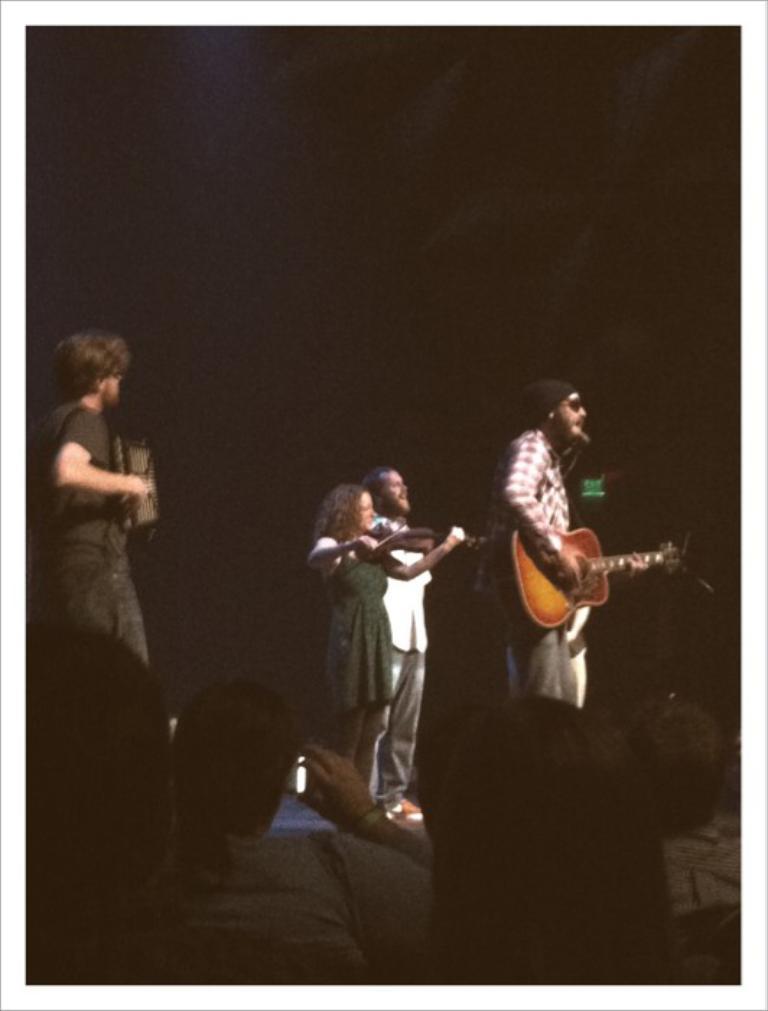How would you summarize this image in a sentence or two? This picture shows few people standing two men playing guitar holding in their hands and we see a woman playing violin and we see audience watching them and a women taking pictures with her mobile holding in her hand 